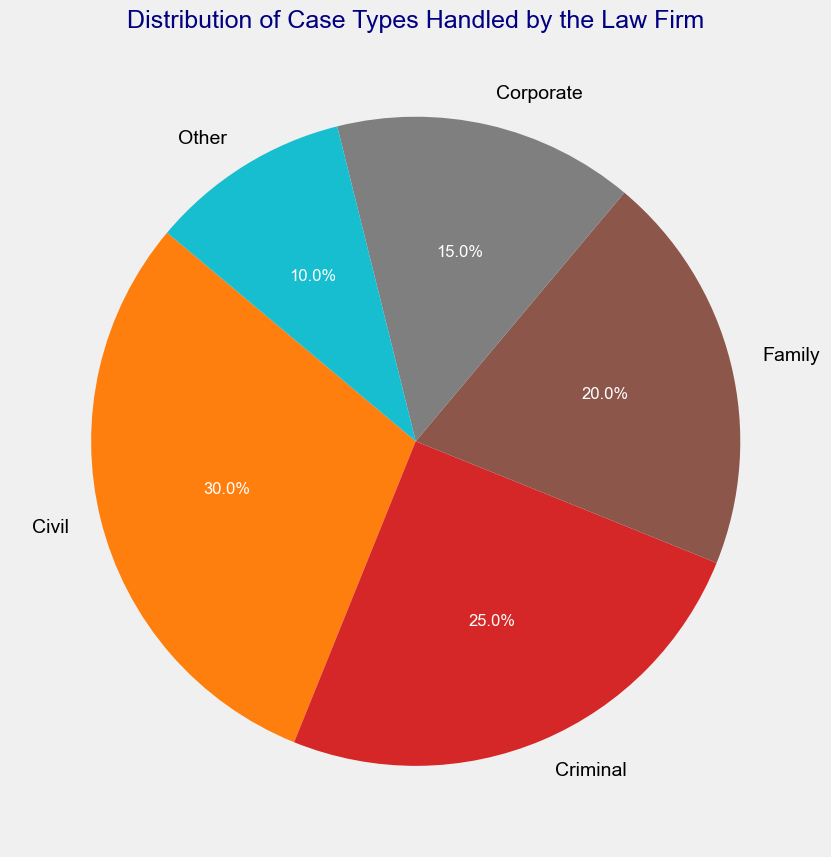What's the case type with the largest percentage? By observing the pie chart, we can see that the 'Civil' slice is the largest, indicating it has the highest percentage of cases handled by the law firm.
Answer: Civil Which case type has the smallest percentage? By looking at the pie chart, the 'Other' slice is the smallest, meaning it has the lowest percentage of cases handled by the law firm.
Answer: Other How much more percentage do civil cases have compared to family cases? The percentage for civil cases is 30%. The percentage for family cases is 20%. Subtracting the percentage of family cases from the percentage of civil cases gives us 30% - 20% = 10%.
Answer: 10% What is the total percentage of cases handled for criminal and corporate types combined? The percentage for criminal cases is 25% and for corporate cases is 15%. Adding them together gives us 25% + 15% = 40%.
Answer: 40% Which case type has a percentage almost half of civil cases? The percentage for civil cases is 30%. The case type that has a percentage close to half of this is 15%, which corresponds to corporate cases.
Answer: Corporate What is the difference in percentage between the highest and lowest case types? The highest percentage case type is civil at 30%, and the lowest is other at 10%. The difference is calculated as 30% - 10% = 20%.
Answer: 20% How do the percentages of family and corporate cases compare? The family case percentage is 20% and the corporate case percentage is 15%. Comparing the two, family cases have 5% more than corporate cases.
Answer: Family cases have 5% more If you combine civil, criminal, and family cases, what percentage of the total cases does the law firm handle? Adding the percentages of civil (30%), criminal (25%), and family (20%) cases together gives us 30% + 25% + 20% = 75%.
Answer: 75% What are the visual attributes of the highest percentage case type in the pie chart? The highest percentage case type, civil, has a larger slice in the pie chart and a distinct color compared to other slices. The size and the label indicating 30% also help identify it.
Answer: Large slice with 30% label Which two case types combined make up exactly half of the law firm’s cases? The two case types whose percentages add up to 50% are criminal (25%) and family (20%). Adding these gives us 25% + 25% = 50%.
Answer: Criminal and Family 